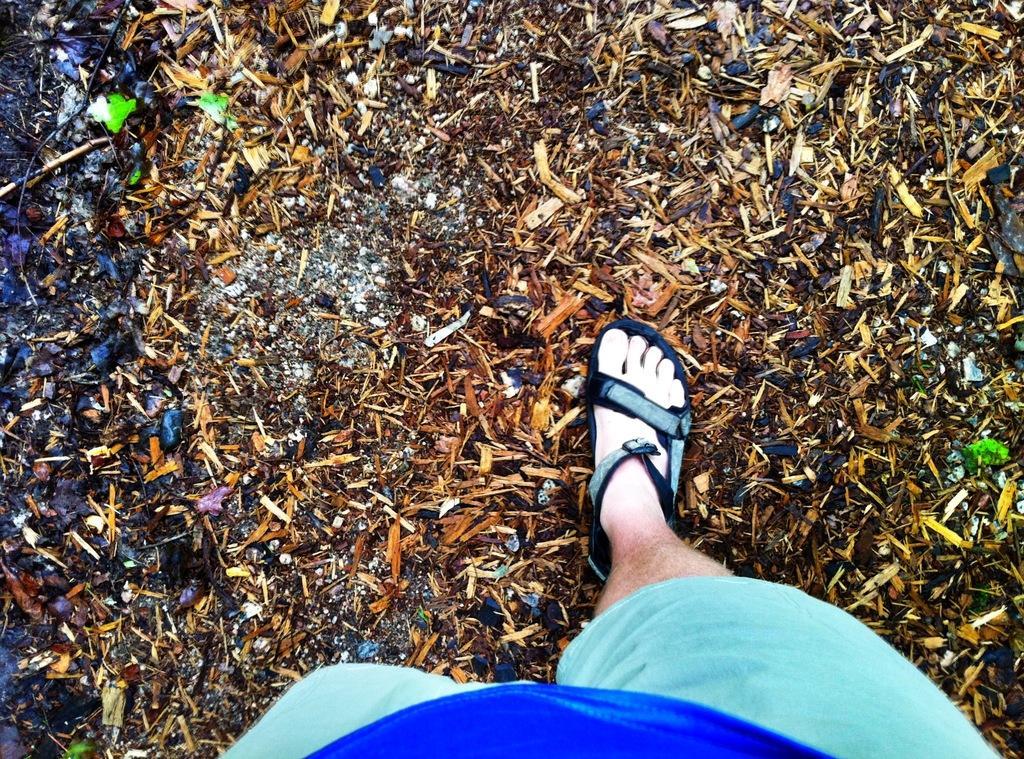Could you give a brief overview of what you see in this image? In this image I can see a person wearing blue colored dress and footwear is standing on the ground. I can see few object on the ground which are brown, black and green in color. 